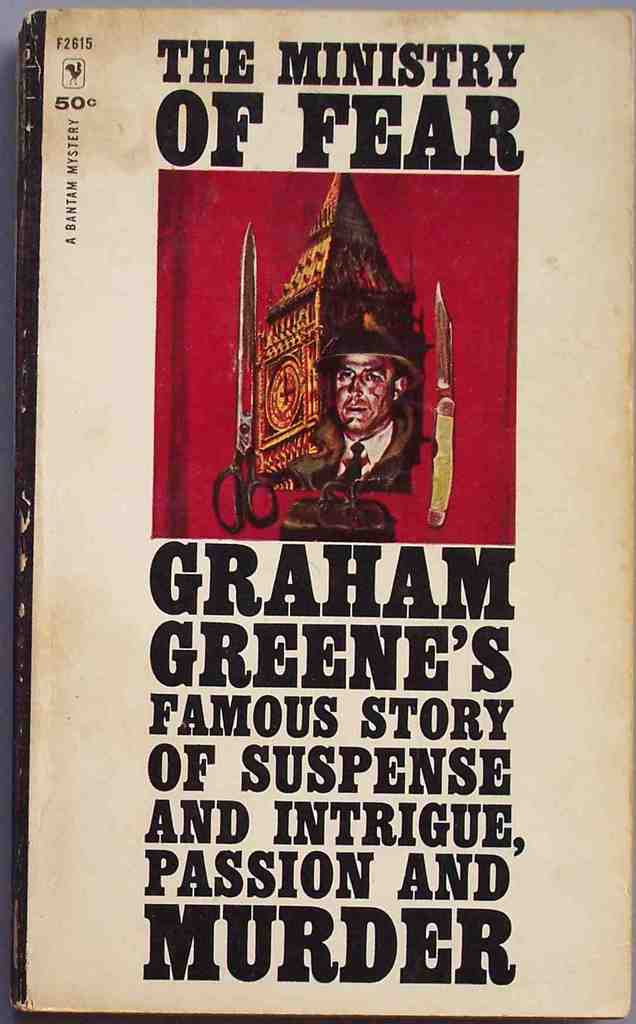What do you see happening in this image? The image depicts the cover of Graham Greene's novel, 'The Ministry of Fear'. It features a striking illustration set against a red background. The image captures a man's face, partially shadowed, and adorned with a hat that is intricately detailed with a feather, signalling perhaps a role of disguise or deceit integral to the novel’s themes of suspense and intrigue. Text above the illustration boldly states the title, 'The Ministry of Fear', while Graham Greene’s name appears below. The cover further teases the reader with a description of the book’s content as a tale filled with 'suspense, intrigue, passion and murder', suggesting a narrative rich in tension and dramatic twists. 